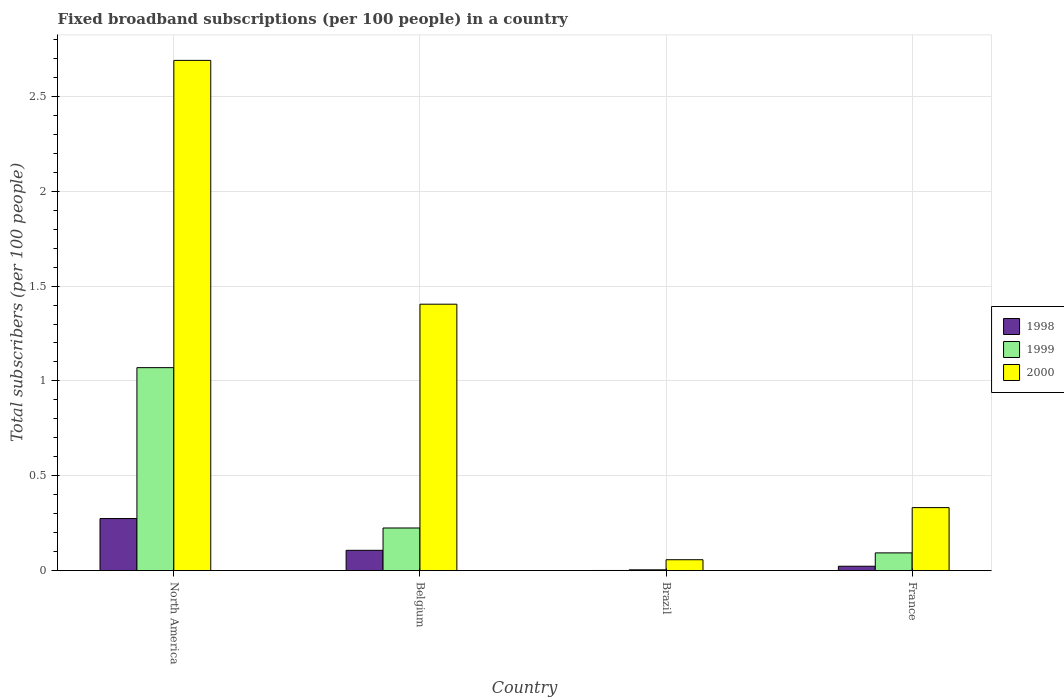How many different coloured bars are there?
Make the answer very short. 3. Are the number of bars per tick equal to the number of legend labels?
Keep it short and to the point. Yes. How many bars are there on the 2nd tick from the left?
Give a very brief answer. 3. What is the number of broadband subscriptions in 1999 in North America?
Provide a succinct answer. 1.07. Across all countries, what is the maximum number of broadband subscriptions in 1998?
Provide a short and direct response. 0.27. Across all countries, what is the minimum number of broadband subscriptions in 2000?
Make the answer very short. 0.06. What is the total number of broadband subscriptions in 2000 in the graph?
Keep it short and to the point. 4.48. What is the difference between the number of broadband subscriptions in 2000 in Brazil and that in France?
Provide a succinct answer. -0.27. What is the difference between the number of broadband subscriptions in 1999 in North America and the number of broadband subscriptions in 1998 in Brazil?
Your answer should be compact. 1.07. What is the average number of broadband subscriptions in 2000 per country?
Keep it short and to the point. 1.12. What is the difference between the number of broadband subscriptions of/in 1999 and number of broadband subscriptions of/in 2000 in Brazil?
Give a very brief answer. -0.05. In how many countries, is the number of broadband subscriptions in 1999 greater than 0.30000000000000004?
Ensure brevity in your answer.  1. What is the ratio of the number of broadband subscriptions in 2000 in Brazil to that in France?
Your answer should be compact. 0.17. Is the number of broadband subscriptions in 1998 in Belgium less than that in North America?
Provide a succinct answer. Yes. What is the difference between the highest and the second highest number of broadband subscriptions in 2000?
Offer a very short reply. -1.07. What is the difference between the highest and the lowest number of broadband subscriptions in 1998?
Your answer should be very brief. 0.27. Is the sum of the number of broadband subscriptions in 1998 in Brazil and France greater than the maximum number of broadband subscriptions in 2000 across all countries?
Offer a very short reply. No. What does the 1st bar from the left in Belgium represents?
Your answer should be compact. 1998. What does the 3rd bar from the right in Brazil represents?
Keep it short and to the point. 1998. How many countries are there in the graph?
Your answer should be compact. 4. What is the difference between two consecutive major ticks on the Y-axis?
Your answer should be compact. 0.5. Are the values on the major ticks of Y-axis written in scientific E-notation?
Give a very brief answer. No. Where does the legend appear in the graph?
Give a very brief answer. Center right. How many legend labels are there?
Provide a succinct answer. 3. What is the title of the graph?
Ensure brevity in your answer.  Fixed broadband subscriptions (per 100 people) in a country. Does "1977" appear as one of the legend labels in the graph?
Give a very brief answer. No. What is the label or title of the Y-axis?
Make the answer very short. Total subscribers (per 100 people). What is the Total subscribers (per 100 people) of 1998 in North America?
Provide a short and direct response. 0.27. What is the Total subscribers (per 100 people) in 1999 in North America?
Keep it short and to the point. 1.07. What is the Total subscribers (per 100 people) of 2000 in North America?
Your answer should be very brief. 2.69. What is the Total subscribers (per 100 people) in 1998 in Belgium?
Give a very brief answer. 0.11. What is the Total subscribers (per 100 people) in 1999 in Belgium?
Ensure brevity in your answer.  0.22. What is the Total subscribers (per 100 people) in 2000 in Belgium?
Ensure brevity in your answer.  1.4. What is the Total subscribers (per 100 people) in 1998 in Brazil?
Offer a very short reply. 0. What is the Total subscribers (per 100 people) in 1999 in Brazil?
Make the answer very short. 0. What is the Total subscribers (per 100 people) in 2000 in Brazil?
Ensure brevity in your answer.  0.06. What is the Total subscribers (per 100 people) in 1998 in France?
Provide a succinct answer. 0.02. What is the Total subscribers (per 100 people) in 1999 in France?
Offer a very short reply. 0.09. What is the Total subscribers (per 100 people) of 2000 in France?
Give a very brief answer. 0.33. Across all countries, what is the maximum Total subscribers (per 100 people) of 1998?
Give a very brief answer. 0.27. Across all countries, what is the maximum Total subscribers (per 100 people) of 1999?
Offer a very short reply. 1.07. Across all countries, what is the maximum Total subscribers (per 100 people) of 2000?
Your answer should be very brief. 2.69. Across all countries, what is the minimum Total subscribers (per 100 people) in 1998?
Offer a very short reply. 0. Across all countries, what is the minimum Total subscribers (per 100 people) in 1999?
Provide a succinct answer. 0. Across all countries, what is the minimum Total subscribers (per 100 people) of 2000?
Ensure brevity in your answer.  0.06. What is the total Total subscribers (per 100 people) of 1998 in the graph?
Provide a succinct answer. 0.4. What is the total Total subscribers (per 100 people) in 1999 in the graph?
Your response must be concise. 1.39. What is the total Total subscribers (per 100 people) of 2000 in the graph?
Your answer should be compact. 4.48. What is the difference between the Total subscribers (per 100 people) of 1998 in North America and that in Belgium?
Your answer should be compact. 0.17. What is the difference between the Total subscribers (per 100 people) of 1999 in North America and that in Belgium?
Offer a terse response. 0.85. What is the difference between the Total subscribers (per 100 people) in 2000 in North America and that in Belgium?
Make the answer very short. 1.29. What is the difference between the Total subscribers (per 100 people) in 1998 in North America and that in Brazil?
Make the answer very short. 0.27. What is the difference between the Total subscribers (per 100 people) of 1999 in North America and that in Brazil?
Your response must be concise. 1.07. What is the difference between the Total subscribers (per 100 people) of 2000 in North America and that in Brazil?
Make the answer very short. 2.63. What is the difference between the Total subscribers (per 100 people) in 1998 in North America and that in France?
Make the answer very short. 0.25. What is the difference between the Total subscribers (per 100 people) of 1999 in North America and that in France?
Your response must be concise. 0.98. What is the difference between the Total subscribers (per 100 people) in 2000 in North America and that in France?
Your answer should be very brief. 2.36. What is the difference between the Total subscribers (per 100 people) in 1998 in Belgium and that in Brazil?
Give a very brief answer. 0.11. What is the difference between the Total subscribers (per 100 people) in 1999 in Belgium and that in Brazil?
Ensure brevity in your answer.  0.22. What is the difference between the Total subscribers (per 100 people) of 2000 in Belgium and that in Brazil?
Provide a short and direct response. 1.35. What is the difference between the Total subscribers (per 100 people) of 1998 in Belgium and that in France?
Make the answer very short. 0.08. What is the difference between the Total subscribers (per 100 people) of 1999 in Belgium and that in France?
Make the answer very short. 0.13. What is the difference between the Total subscribers (per 100 people) of 2000 in Belgium and that in France?
Offer a terse response. 1.07. What is the difference between the Total subscribers (per 100 people) of 1998 in Brazil and that in France?
Your answer should be very brief. -0.02. What is the difference between the Total subscribers (per 100 people) in 1999 in Brazil and that in France?
Provide a short and direct response. -0.09. What is the difference between the Total subscribers (per 100 people) of 2000 in Brazil and that in France?
Ensure brevity in your answer.  -0.27. What is the difference between the Total subscribers (per 100 people) in 1998 in North America and the Total subscribers (per 100 people) in 1999 in Belgium?
Your answer should be compact. 0.05. What is the difference between the Total subscribers (per 100 people) of 1998 in North America and the Total subscribers (per 100 people) of 2000 in Belgium?
Give a very brief answer. -1.13. What is the difference between the Total subscribers (per 100 people) of 1999 in North America and the Total subscribers (per 100 people) of 2000 in Belgium?
Your response must be concise. -0.33. What is the difference between the Total subscribers (per 100 people) in 1998 in North America and the Total subscribers (per 100 people) in 1999 in Brazil?
Your answer should be very brief. 0.27. What is the difference between the Total subscribers (per 100 people) in 1998 in North America and the Total subscribers (per 100 people) in 2000 in Brazil?
Offer a very short reply. 0.22. What is the difference between the Total subscribers (per 100 people) of 1999 in North America and the Total subscribers (per 100 people) of 2000 in Brazil?
Your answer should be very brief. 1.01. What is the difference between the Total subscribers (per 100 people) in 1998 in North America and the Total subscribers (per 100 people) in 1999 in France?
Ensure brevity in your answer.  0.18. What is the difference between the Total subscribers (per 100 people) of 1998 in North America and the Total subscribers (per 100 people) of 2000 in France?
Ensure brevity in your answer.  -0.06. What is the difference between the Total subscribers (per 100 people) in 1999 in North America and the Total subscribers (per 100 people) in 2000 in France?
Offer a terse response. 0.74. What is the difference between the Total subscribers (per 100 people) of 1998 in Belgium and the Total subscribers (per 100 people) of 1999 in Brazil?
Provide a short and direct response. 0.1. What is the difference between the Total subscribers (per 100 people) of 1998 in Belgium and the Total subscribers (per 100 people) of 2000 in Brazil?
Provide a short and direct response. 0.05. What is the difference between the Total subscribers (per 100 people) of 1999 in Belgium and the Total subscribers (per 100 people) of 2000 in Brazil?
Ensure brevity in your answer.  0.17. What is the difference between the Total subscribers (per 100 people) of 1998 in Belgium and the Total subscribers (per 100 people) of 1999 in France?
Ensure brevity in your answer.  0.01. What is the difference between the Total subscribers (per 100 people) in 1998 in Belgium and the Total subscribers (per 100 people) in 2000 in France?
Your answer should be compact. -0.23. What is the difference between the Total subscribers (per 100 people) in 1999 in Belgium and the Total subscribers (per 100 people) in 2000 in France?
Ensure brevity in your answer.  -0.11. What is the difference between the Total subscribers (per 100 people) in 1998 in Brazil and the Total subscribers (per 100 people) in 1999 in France?
Provide a short and direct response. -0.09. What is the difference between the Total subscribers (per 100 people) in 1998 in Brazil and the Total subscribers (per 100 people) in 2000 in France?
Your answer should be very brief. -0.33. What is the difference between the Total subscribers (per 100 people) in 1999 in Brazil and the Total subscribers (per 100 people) in 2000 in France?
Keep it short and to the point. -0.33. What is the average Total subscribers (per 100 people) of 1998 per country?
Keep it short and to the point. 0.1. What is the average Total subscribers (per 100 people) in 1999 per country?
Provide a short and direct response. 0.35. What is the average Total subscribers (per 100 people) of 2000 per country?
Provide a short and direct response. 1.12. What is the difference between the Total subscribers (per 100 people) of 1998 and Total subscribers (per 100 people) of 1999 in North America?
Provide a succinct answer. -0.8. What is the difference between the Total subscribers (per 100 people) in 1998 and Total subscribers (per 100 people) in 2000 in North America?
Offer a very short reply. -2.42. What is the difference between the Total subscribers (per 100 people) in 1999 and Total subscribers (per 100 people) in 2000 in North America?
Provide a short and direct response. -1.62. What is the difference between the Total subscribers (per 100 people) in 1998 and Total subscribers (per 100 people) in 1999 in Belgium?
Keep it short and to the point. -0.12. What is the difference between the Total subscribers (per 100 people) in 1998 and Total subscribers (per 100 people) in 2000 in Belgium?
Provide a short and direct response. -1.3. What is the difference between the Total subscribers (per 100 people) in 1999 and Total subscribers (per 100 people) in 2000 in Belgium?
Your response must be concise. -1.18. What is the difference between the Total subscribers (per 100 people) in 1998 and Total subscribers (per 100 people) in 1999 in Brazil?
Keep it short and to the point. -0. What is the difference between the Total subscribers (per 100 people) in 1998 and Total subscribers (per 100 people) in 2000 in Brazil?
Offer a very short reply. -0.06. What is the difference between the Total subscribers (per 100 people) of 1999 and Total subscribers (per 100 people) of 2000 in Brazil?
Your answer should be very brief. -0.05. What is the difference between the Total subscribers (per 100 people) of 1998 and Total subscribers (per 100 people) of 1999 in France?
Your response must be concise. -0.07. What is the difference between the Total subscribers (per 100 people) in 1998 and Total subscribers (per 100 people) in 2000 in France?
Keep it short and to the point. -0.31. What is the difference between the Total subscribers (per 100 people) of 1999 and Total subscribers (per 100 people) of 2000 in France?
Your answer should be very brief. -0.24. What is the ratio of the Total subscribers (per 100 people) in 1998 in North America to that in Belgium?
Provide a short and direct response. 2.57. What is the ratio of the Total subscribers (per 100 people) in 1999 in North America to that in Belgium?
Offer a very short reply. 4.76. What is the ratio of the Total subscribers (per 100 people) in 2000 in North America to that in Belgium?
Your response must be concise. 1.92. What is the ratio of the Total subscribers (per 100 people) of 1998 in North America to that in Brazil?
Your answer should be compact. 465.15. What is the ratio of the Total subscribers (per 100 people) of 1999 in North America to that in Brazil?
Make the answer very short. 262.9. What is the ratio of the Total subscribers (per 100 people) of 2000 in North America to that in Brazil?
Give a very brief answer. 46.94. What is the ratio of the Total subscribers (per 100 people) in 1998 in North America to that in France?
Your answer should be compact. 11.95. What is the ratio of the Total subscribers (per 100 people) of 1999 in North America to that in France?
Provide a succinct answer. 11.46. What is the ratio of the Total subscribers (per 100 people) in 2000 in North America to that in France?
Give a very brief answer. 8.1. What is the ratio of the Total subscribers (per 100 people) of 1998 in Belgium to that in Brazil?
Your answer should be compact. 181.1. What is the ratio of the Total subscribers (per 100 people) in 1999 in Belgium to that in Brazil?
Provide a succinct answer. 55.18. What is the ratio of the Total subscribers (per 100 people) of 2000 in Belgium to that in Brazil?
Ensure brevity in your answer.  24.51. What is the ratio of the Total subscribers (per 100 people) in 1998 in Belgium to that in France?
Keep it short and to the point. 4.65. What is the ratio of the Total subscribers (per 100 people) of 1999 in Belgium to that in France?
Your response must be concise. 2.4. What is the ratio of the Total subscribers (per 100 people) of 2000 in Belgium to that in France?
Your answer should be very brief. 4.23. What is the ratio of the Total subscribers (per 100 people) of 1998 in Brazil to that in France?
Offer a terse response. 0.03. What is the ratio of the Total subscribers (per 100 people) in 1999 in Brazil to that in France?
Keep it short and to the point. 0.04. What is the ratio of the Total subscribers (per 100 people) in 2000 in Brazil to that in France?
Make the answer very short. 0.17. What is the difference between the highest and the second highest Total subscribers (per 100 people) in 1998?
Ensure brevity in your answer.  0.17. What is the difference between the highest and the second highest Total subscribers (per 100 people) of 1999?
Offer a terse response. 0.85. What is the difference between the highest and the second highest Total subscribers (per 100 people) in 2000?
Make the answer very short. 1.29. What is the difference between the highest and the lowest Total subscribers (per 100 people) in 1998?
Offer a terse response. 0.27. What is the difference between the highest and the lowest Total subscribers (per 100 people) of 1999?
Make the answer very short. 1.07. What is the difference between the highest and the lowest Total subscribers (per 100 people) of 2000?
Give a very brief answer. 2.63. 